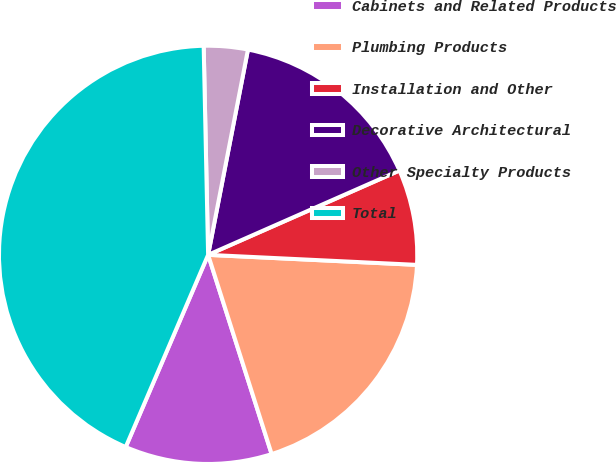Convert chart to OTSL. <chart><loc_0><loc_0><loc_500><loc_500><pie_chart><fcel>Cabinets and Related Products<fcel>Plumbing Products<fcel>Installation and Other<fcel>Decorative Architectural<fcel>Other Specialty Products<fcel>Total<nl><fcel>11.36%<fcel>19.32%<fcel>7.37%<fcel>15.34%<fcel>3.39%<fcel>43.21%<nl></chart> 